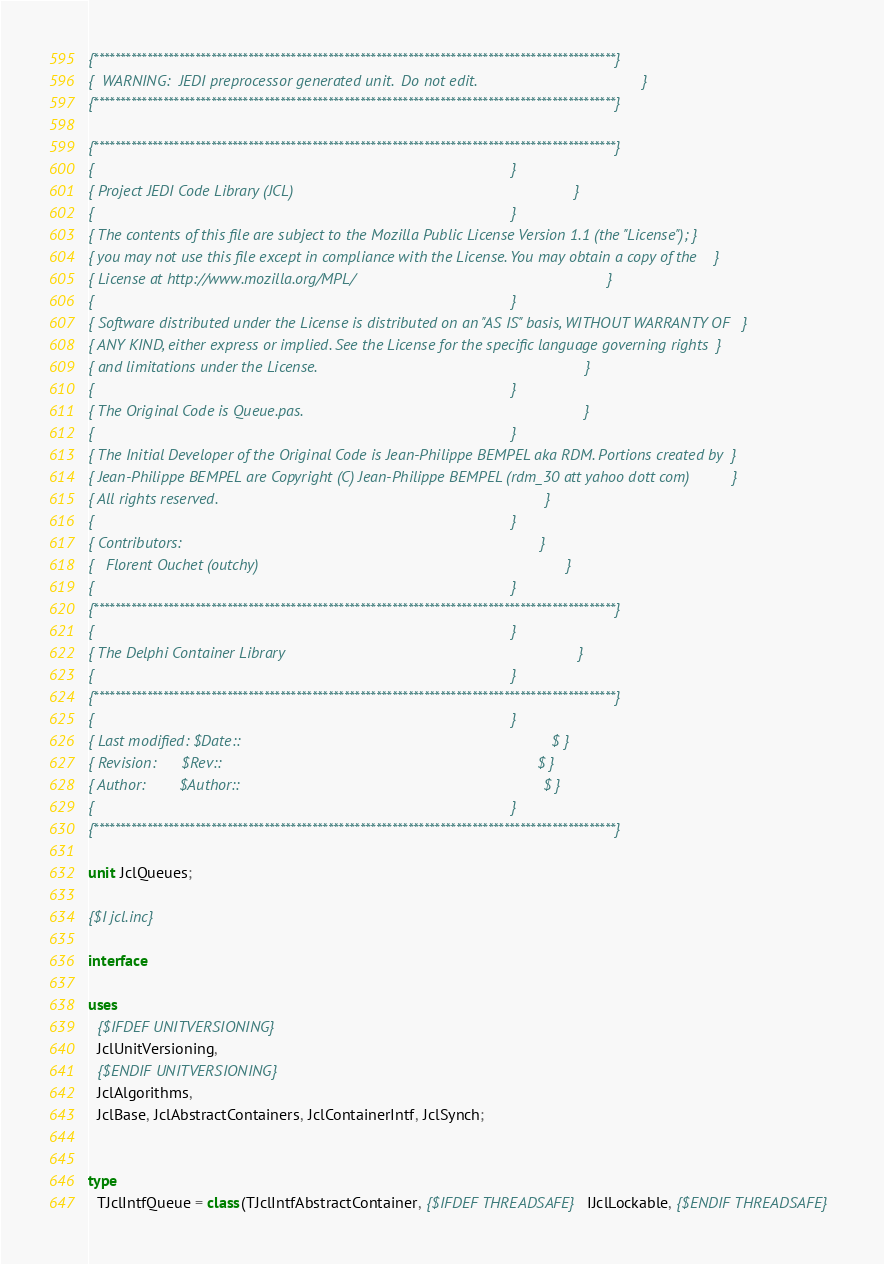Convert code to text. <code><loc_0><loc_0><loc_500><loc_500><_Pascal_>{**************************************************************************************************}
{  WARNING:  JEDI preprocessor generated unit.  Do not edit.                                       }
{**************************************************************************************************}

{**************************************************************************************************}
{                                                                                                  }
{ Project JEDI Code Library (JCL)                                                                  }
{                                                                                                  }
{ The contents of this file are subject to the Mozilla Public License Version 1.1 (the "License"); }
{ you may not use this file except in compliance with the License. You may obtain a copy of the    }
{ License at http://www.mozilla.org/MPL/                                                           }
{                                                                                                  }
{ Software distributed under the License is distributed on an "AS IS" basis, WITHOUT WARRANTY OF   }
{ ANY KIND, either express or implied. See the License for the specific language governing rights  }
{ and limitations under the License.                                                               }
{                                                                                                  }
{ The Original Code is Queue.pas.                                                                  }
{                                                                                                  }
{ The Initial Developer of the Original Code is Jean-Philippe BEMPEL aka RDM. Portions created by  }
{ Jean-Philippe BEMPEL are Copyright (C) Jean-Philippe BEMPEL (rdm_30 att yahoo dott com)          }
{ All rights reserved.                                                                             }
{                                                                                                  }
{ Contributors:                                                                                    }
{   Florent Ouchet (outchy)                                                                        }
{                                                                                                  }
{**************************************************************************************************}
{                                                                                                  }
{ The Delphi Container Library                                                                     }
{                                                                                                  }
{**************************************************************************************************}
{                                                                                                  }
{ Last modified: $Date::                                                                         $ }
{ Revision:      $Rev::                                                                          $ }
{ Author:        $Author::                                                                       $ }
{                                                                                                  }
{**************************************************************************************************}

unit JclQueues;

{$I jcl.inc}

interface

uses
  {$IFDEF UNITVERSIONING}
  JclUnitVersioning,
  {$ENDIF UNITVERSIONING}
  JclAlgorithms,
  JclBase, JclAbstractContainers, JclContainerIntf, JclSynch;


type
  TJclIntfQueue = class(TJclIntfAbstractContainer, {$IFDEF THREADSAFE} IJclLockable, {$ENDIF THREADSAFE}</code> 